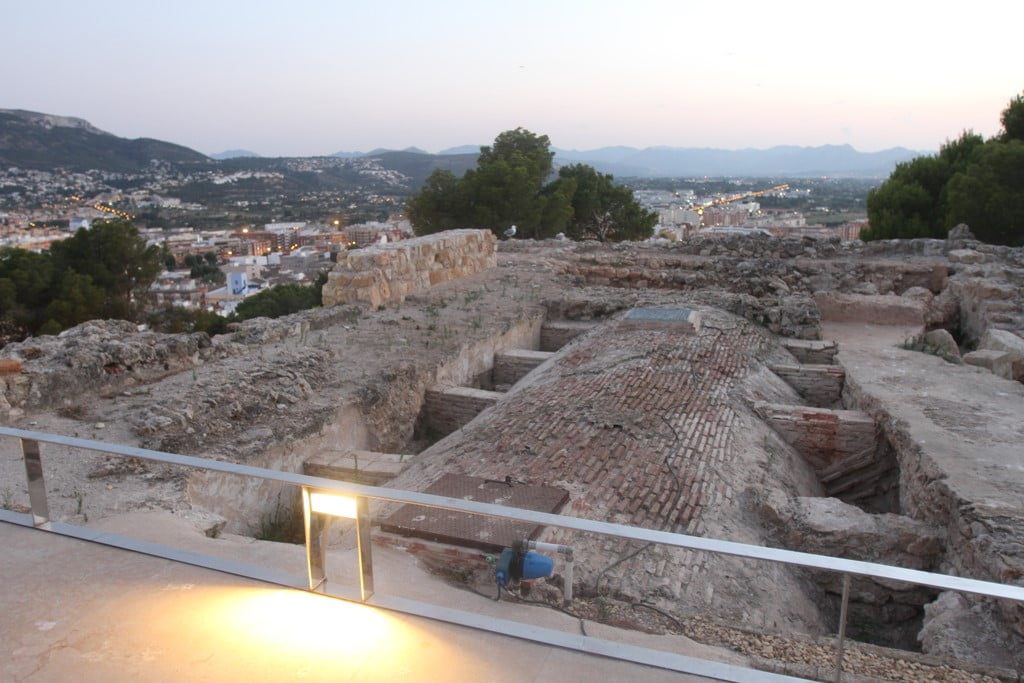What time of day is captured in this image, and how does it affect the overall ambiance? The image captures the enchanting twilight hour, likely at sunset given the orientation and fading light. At this time, the sky transitions through a stunning palette from blue to a soft pink, casting a mystical glow that enhances the historic charm of the ruins. This serene backdrop, contrasted with the warm yellow hues from the ground lights, not only accentuates the age-worn textures of the stones but also invites a contemplative mood. This interplay of light magnifies the ruins' stoic presence, offering a visual narrative of past and present intertwined. 